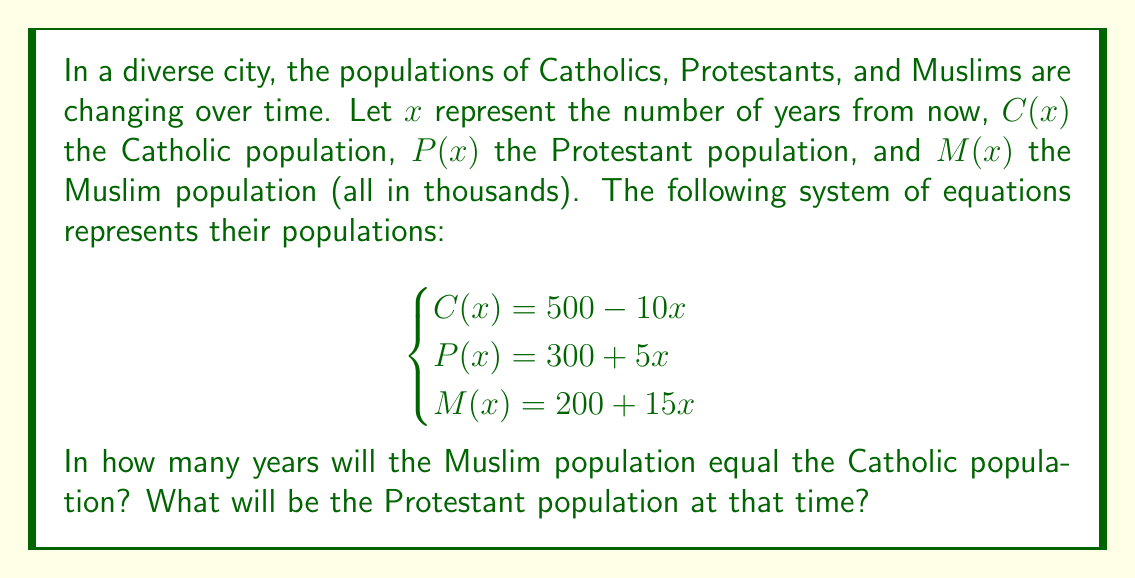Solve this math problem. To solve this problem, we need to follow these steps:

1) First, we need to find when the Muslim population equals the Catholic population. This means we need to solve the equation:

   $C(x) = M(x)$

2) Substituting the given equations:

   $500 - 10x = 200 + 15x$

3) Solve for $x$:
   
   $500 - 200 = 15x + 10x$
   $300 = 25x$
   $x = 12$

4) This means that in 12 years, the Muslim population will equal the Catholic population.

5) To find the Protestant population at that time, we substitute $x = 12$ into the equation for $P(x)$:

   $P(12) = 300 + 5(12) = 300 + 60 = 360$

Therefore, in 12 years, when the Muslim and Catholic populations are equal, the Protestant population will be 360,000.
Answer: The Muslim population will equal the Catholic population in 12 years. At that time, the Protestant population will be 360,000. 